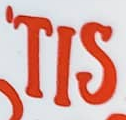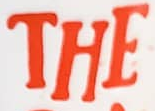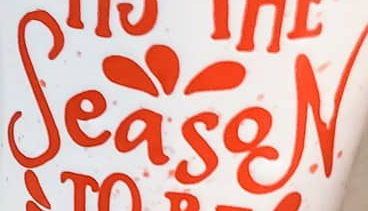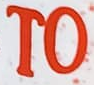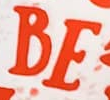Identify the words shown in these images in order, separated by a semicolon. 'TIS; THE; SeasoN; TO; BE 